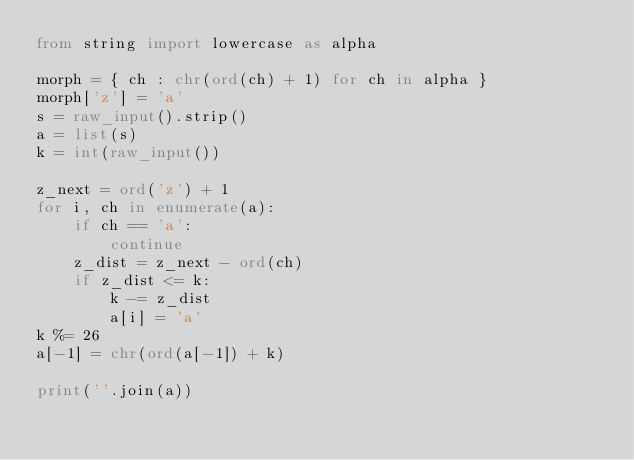Convert code to text. <code><loc_0><loc_0><loc_500><loc_500><_Python_>from string import lowercase as alpha

morph = { ch : chr(ord(ch) + 1) for ch in alpha }
morph['z'] = 'a'
s = raw_input().strip()
a = list(s)
k = int(raw_input())

z_next = ord('z') + 1
for i, ch in enumerate(a):
    if ch == 'a':
        continue
    z_dist = z_next - ord(ch) 
    if z_dist <= k:
        k -= z_dist
        a[i] = 'a'
k %= 26
a[-1] = chr(ord(a[-1]) + k)

print(''.join(a))</code> 